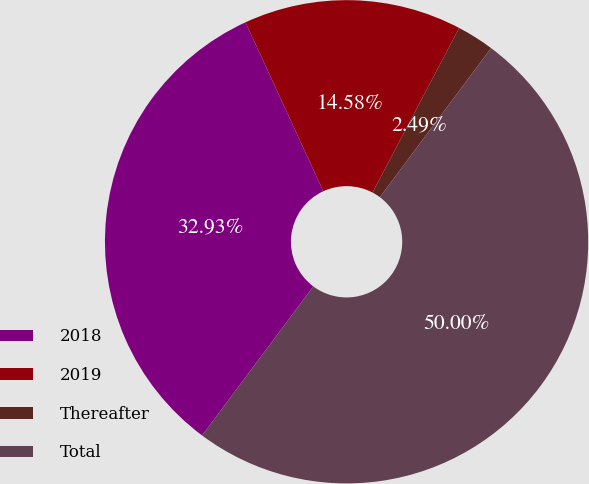<chart> <loc_0><loc_0><loc_500><loc_500><pie_chart><fcel>2018<fcel>2019<fcel>Thereafter<fcel>Total<nl><fcel>32.93%<fcel>14.58%<fcel>2.49%<fcel>50.0%<nl></chart> 